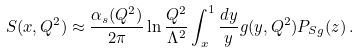Convert formula to latex. <formula><loc_0><loc_0><loc_500><loc_500>S ( x , Q ^ { 2 } ) \approx { \frac { \alpha _ { s } ( Q ^ { 2 } ) } { 2 \pi } } \ln { \frac { Q ^ { 2 } } { \Lambda ^ { 2 } } } \int _ { x } ^ { 1 } { \frac { d y } { y } } g ( y , Q ^ { 2 } ) P _ { S g } ( z ) \, .</formula> 